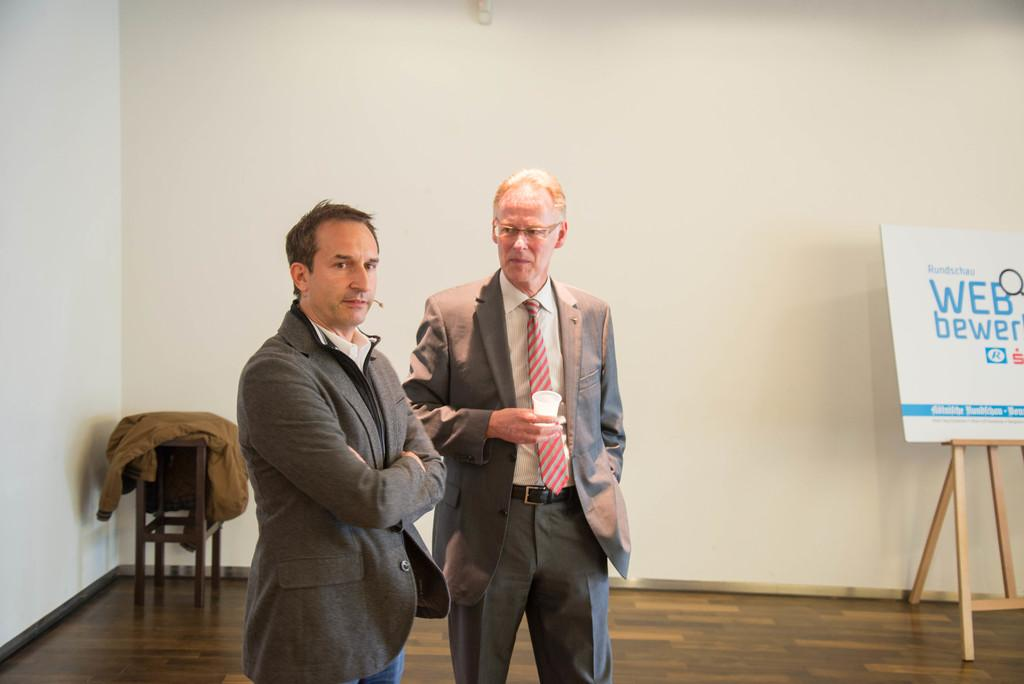What can be seen in the background of the image? There is a wall in the background of the image. What is placed on the chair in the image? There is a jacket on a chair in the image. What is the purpose of the whiteboard with a stand in the image? The whiteboard with a stand is likely used for writing or displaying information. What is visible beneath the men in the image? The floor is visible in the image. How many people are present in the image? There are two men standing in the image. What is one of the men holding in his hand? One of the men is holding a glass in his hand. What type of match is being played in the image? There is no match being played in the image; it features a jacket on a chair, a whiteboard with a stand, and two men standing. How does the temper of the men affect the image? The temper of the men is not mentioned or depicted in the image, so it cannot be determined how it affects the image. 